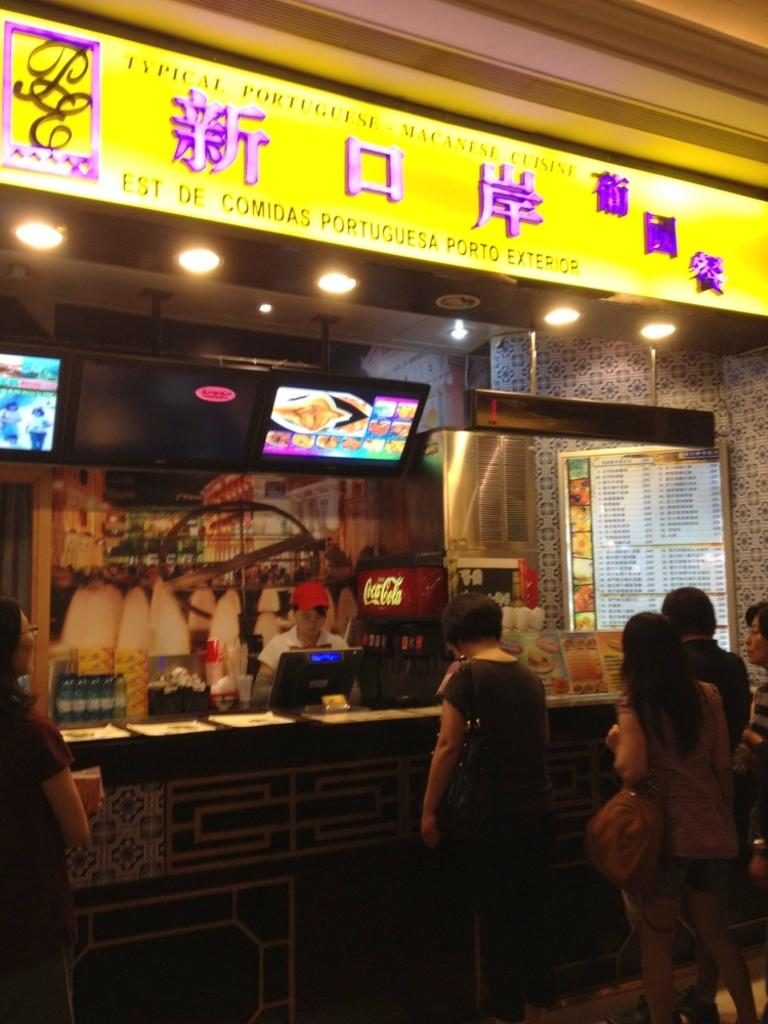How many people are present in the image? There are people in the image, but the exact number cannot be determined from the provided facts. What type of objects can be seen in the image? There are bottles, a monitor, boards, screens, papers, and lights visible in the image. What is the background of the image made of? There is a wall in the image, which suggests the background is made of a solid material like concrete or brick. What type of jewel is being held by the person in the image? There is no mention of a jewel or a person holding a jewel in the provided facts, so this cannot be answered definitively. 